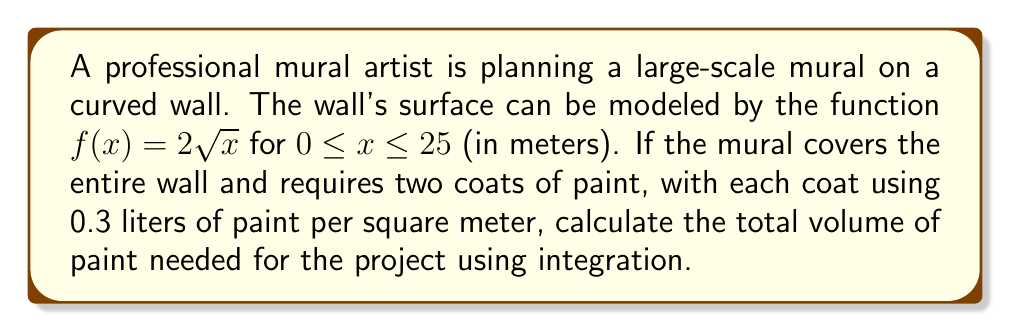Provide a solution to this math problem. To solve this problem, we'll follow these steps:

1) First, we need to find the surface area of the wall using the arc length formula for a function $y = f(x)$:

   $$L = \int_a^b \sqrt{1 + [f'(x)]^2} dx$$

2) For $f(x) = 2\sqrt{x}$, we find $f'(x) = \frac{1}{\sqrt{x}}$

3) Substituting into the arc length formula:

   $$L = \int_0^{25} \sqrt{1 + (\frac{1}{\sqrt{x}})^2} dx$$

4) Simplify under the square root:

   $$L = \int_0^{25} \sqrt{1 + \frac{1}{x}} dx$$

5) Substitute $u = \sqrt{x}$, so $du = \frac{1}{2\sqrt{x}}dx$ or $dx = 2udu$:

   $$L = \int_0^5 \sqrt{1 + \frac{1}{u^2}} \cdot 2u du$$

6) This integral can be solved using trigonometric substitution, but for brevity, we'll state the result:

   $$L = [u\sqrt{u^2+1} + \ln(u + \sqrt{u^2+1})]_0^5$$

7) Evaluating at the limits:

   $$L = 5\sqrt{26} + \ln(5 + \sqrt{26}) - 0 \approx 30.65 \text{ meters}$$

8) Now, we need to calculate the area. The width of the wall is 25 meters, so:

   Area $= 30.65 \cdot 25 = 766.25 \text{ square meters}$

9) Each coat uses 0.3 liters per square meter, and we need two coats:

   Paint needed $= 766.25 \cdot 0.3 \cdot 2 = 459.75 \text{ liters}$
Answer: 459.75 liters 